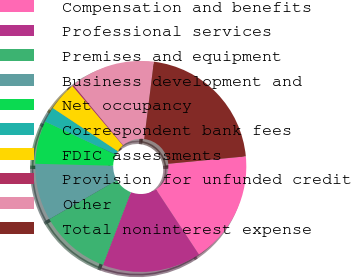Convert chart. <chart><loc_0><loc_0><loc_500><loc_500><pie_chart><fcel>Compensation and benefits<fcel>Professional services<fcel>Premises and equipment<fcel>Business development and<fcel>Net occupancy<fcel>Correspondent bank fees<fcel>FDIC assessments<fcel>Provision for unfunded credit<fcel>Other<fcel>Total noninterest expense<nl><fcel>17.24%<fcel>15.11%<fcel>10.85%<fcel>8.72%<fcel>6.59%<fcel>2.34%<fcel>4.47%<fcel>0.21%<fcel>12.98%<fcel>21.5%<nl></chart> 